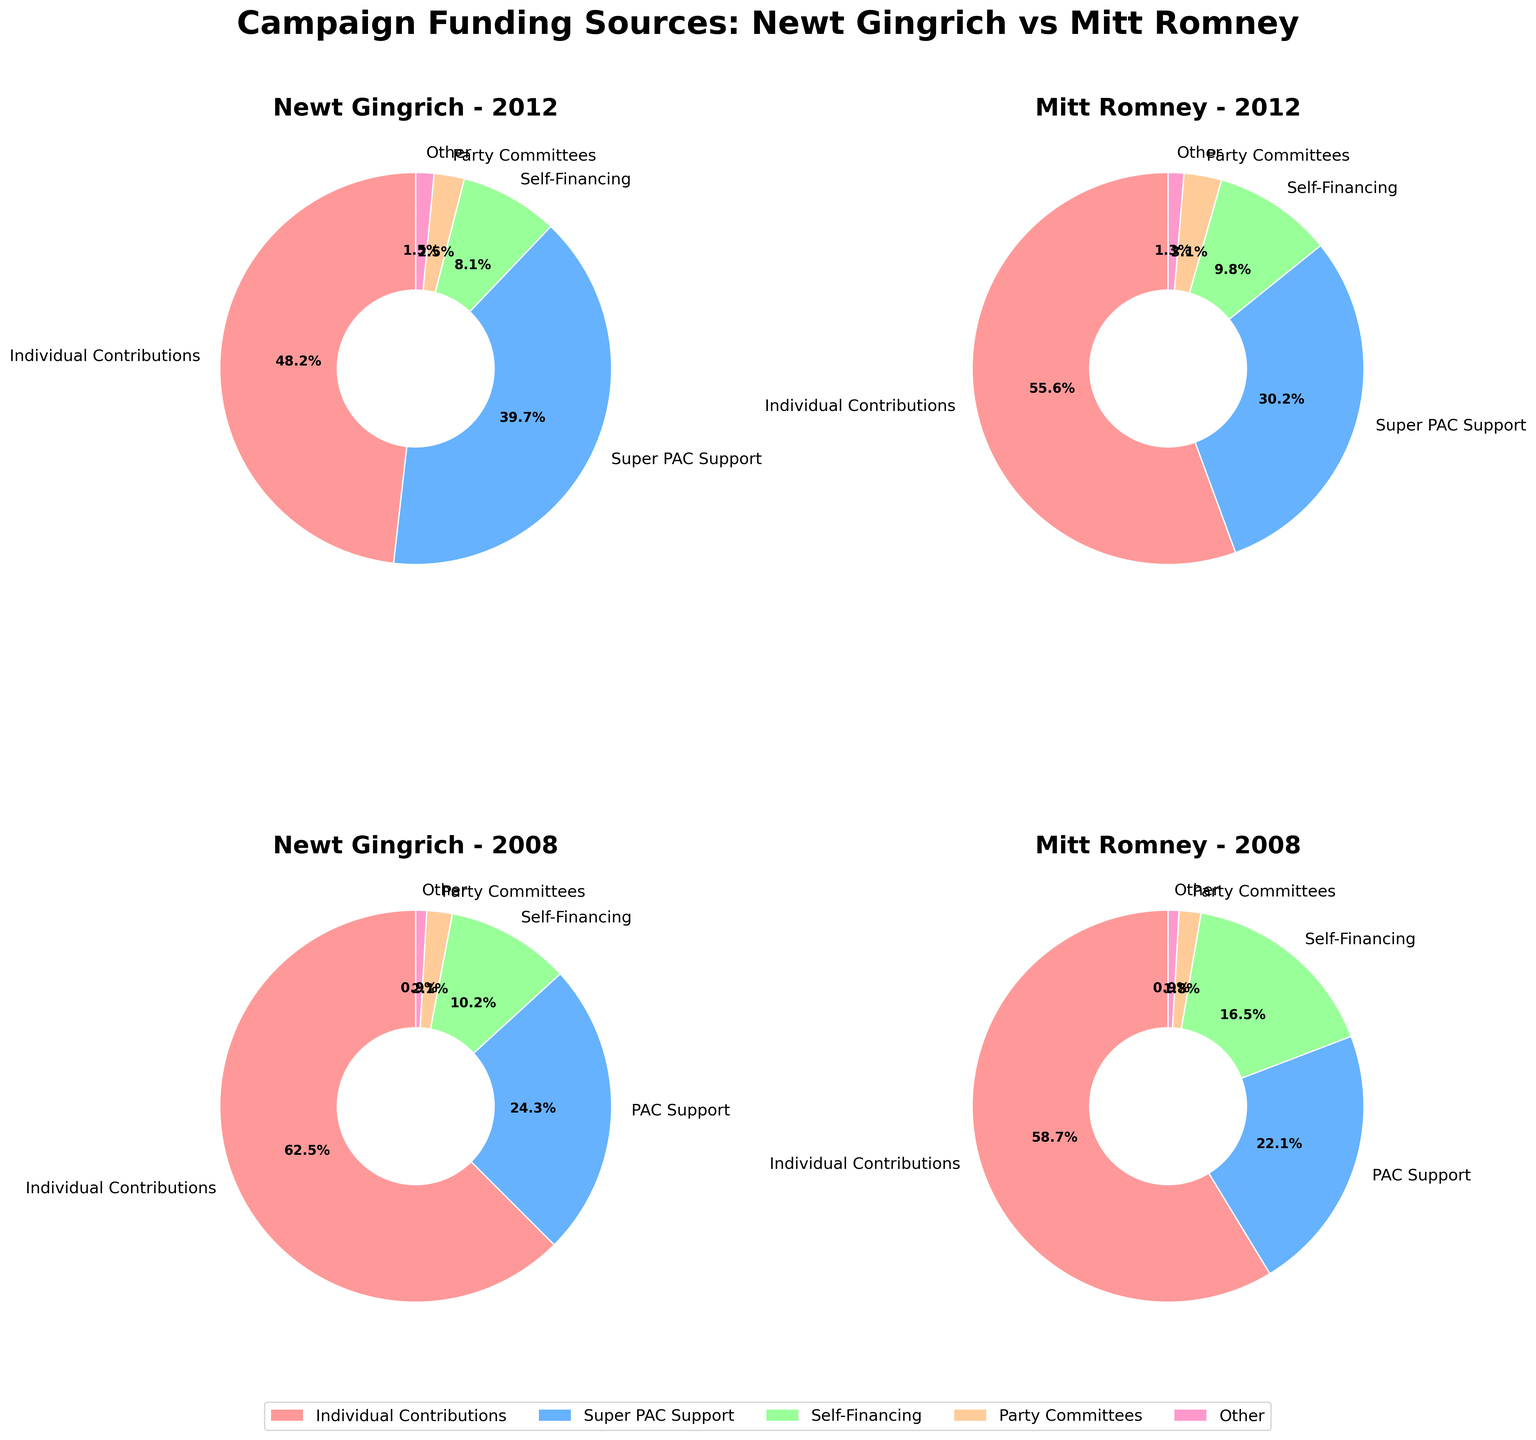Which year had higher individual contributions for Newt Gingrich? To determine this, compare the individual contributions percentage for Newt Gingrich in 2008 and 2012. The 2008 chart shows 62.5% while the 2012 chart shows 48.2%.
Answer: 2008 What is the total percentage of self-financing and PAC support for Mitt Romney in 2008? Add the percentages of self-financing (16.5%) and PAC support (22.1%) for Mitt Romney in 2008 from the respective pie chart. 16.5% + 22.1% = 38.6%
Answer: 38.6% Which candidate had a smaller percentage of party committee contributions in 2012? Compare the party committee contributions for Newt Gingrich (2.5%) and Mitt Romney (3.1%) in 2012 from their respective pie charts. Gingrich’s percentage is smaller.
Answer: Newt Gingrich Among the given funding sources in 2012, whose Super PAC support percentage was closer to 40%? Compare the Super PAC support percentages for Newt Gingrich (39.7%) and Mitt Romney (30.2%) in 2012. Gingrich's percentage is closer to 40%.
Answer: Newt Gingrich Which year had a higher overall "Other" category percentage for both candidates combined? Sum the "Other" category percentages for both candidates in 2008 (0.9% for each) and in 2012 (1.5% for Gingrich and 1.3% for Romney). 2008 total is 1.8%, while 2012 total is 2.8%.
Answer: 2012 Did Mitt Romney or Newt Gingrich have a higher percentage of Self-Financing in 2012? Compare the self-financing percentages for Newt Gingrich (8.1%) and Mitt Romney (9.8%) in 2012. Romney’s percentage is higher.
Answer: Mitt Romney For Newt Gingrich in 2008, what is the combined percentage of PAC Support and Self-Financing? Add the PAC Support (24.3%) and Self-Financing (10.2%) percentages for Newt Gingrich in 2008. 24.3% + 10.2% = 34.5%
Answer: 34.5% Between Gingrich and Romney, who had a higher percentage of individual contributions in both 2008 and 2012? Compare the individual contributions for Newt Gingrich and Mitt Romney in both 2008 (Gingrich: 62.5%, Romney: 58.7%) and 2012 (Gingrich: 48.2%, Romney: 55.6%). Gingrich is higher in 2008, but Romney is higher in 2012.
Answer: Split: Gingrich (2008), Romney (2012) In 2008, compare the sum of Individual Contributions and Self-Financing percentages for both candidates. Who had a higher sum? Calculate the sums: Gingrich - Individual (62.5%) + Self-Financing (10.2%) = 72.7%; Romney - Individual (58.7%) + Self-Financing (16.5%) = 75.2%. Romney’s sum is higher.
Answer: Mitt Romney 